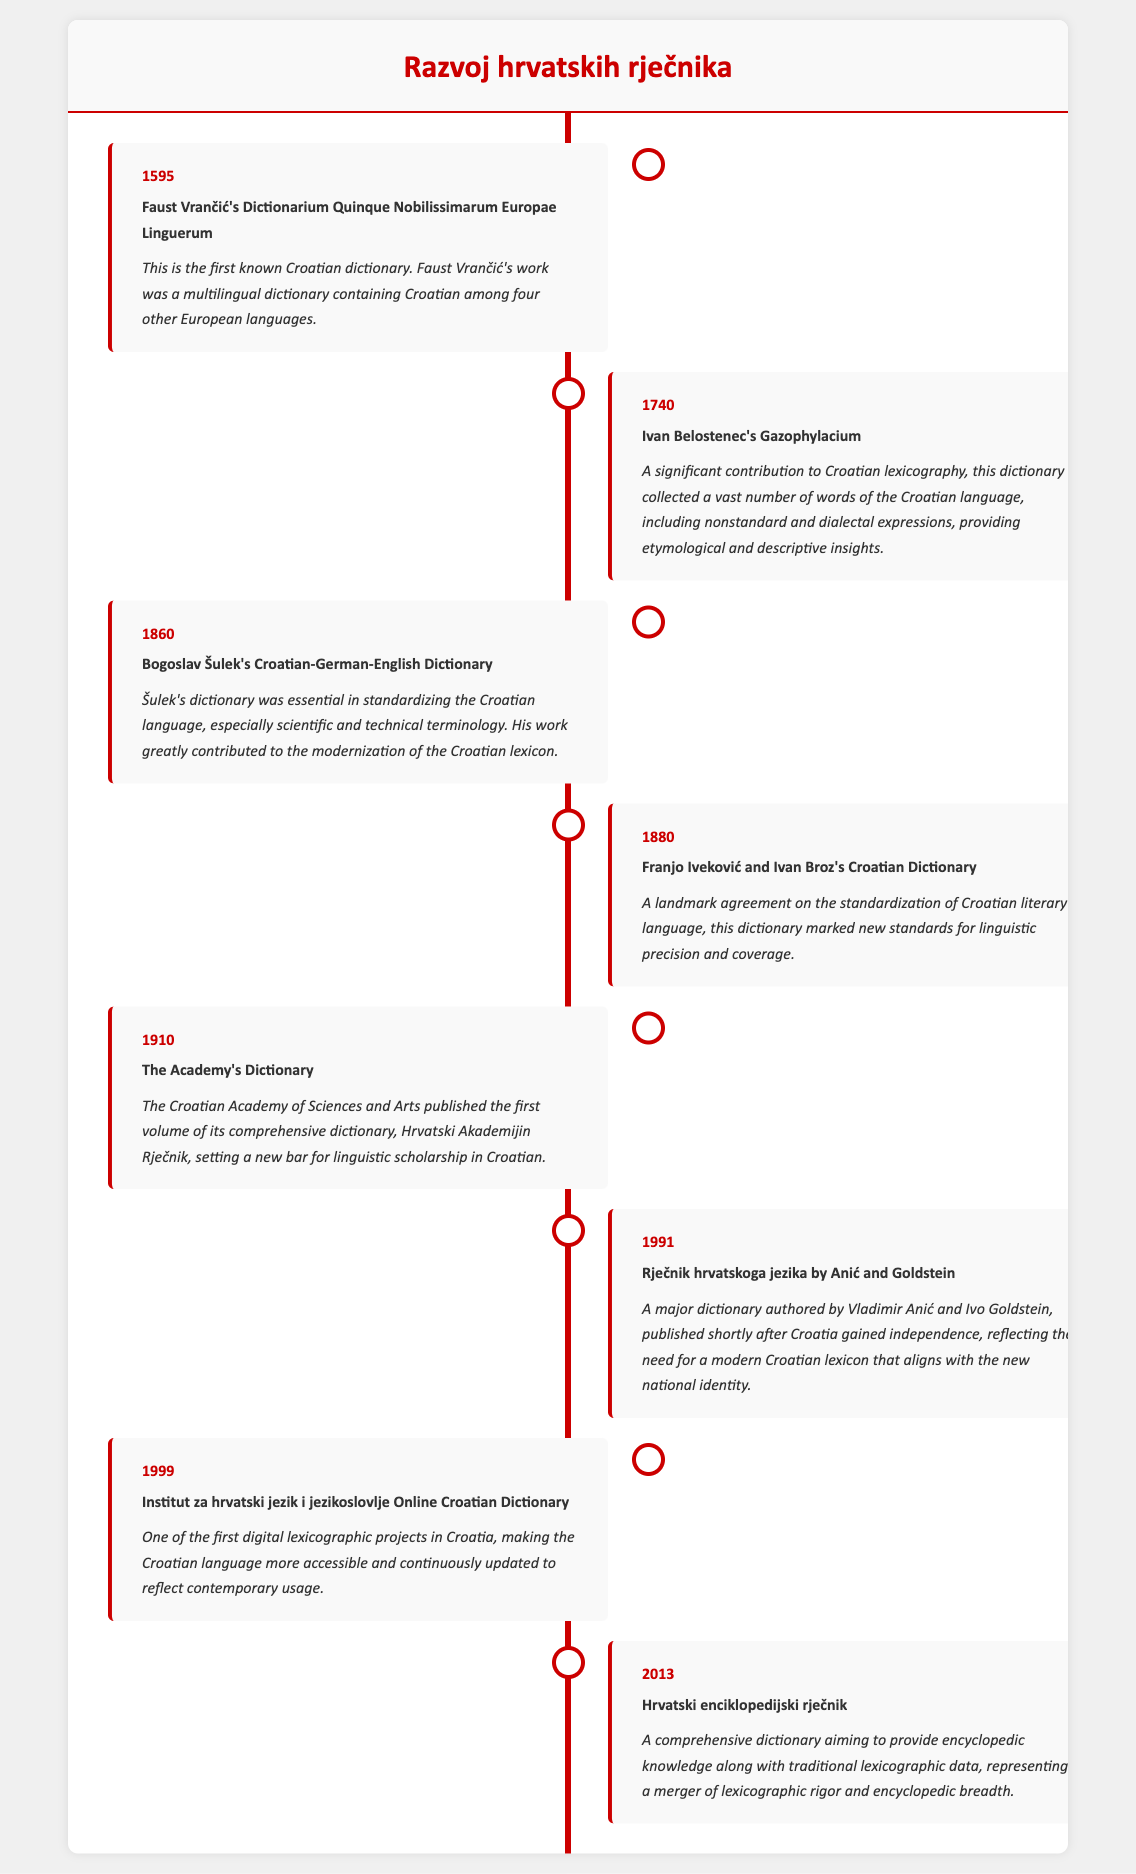What year was the first known Croatian dictionary published? The document mentions that the first known Croatian dictionary, Faust Vrančić's Dictionarium, was published in 1595.
Answer: 1595 Who authored the Croatian-German-English Dictionary in 1860? The document states that Bogoslav Šulek authored the Croatian-German-English Dictionary in 1860.
Answer: Bogoslav Šulek Which dictionary was published shortly after Croatia gained independence? The document indicates that the Rječnik hrvatskoga jezika by Anić and Goldstein was published shortly after independence in 1991.
Answer: Rječnik hrvatskoga jezika by Anić and Goldstein What significant achievement was made in 1910? The document notes that the Croatian Academy of Sciences and Arts published the first volume of its comprehensive dictionary in 1910.
Answer: The Academy's Dictionary In what year was the Online Croatian Dictionary initiated? According to the document, the Online Croatian Dictionary was initiated in 1999.
Answer: 1999 What was the primary objective of Ivan Belostenec's Gazophylacium? The description states that it aimed to collect a vast number of words of the Croatian language, providing etymological and descriptive insights.
Answer: Collection of Croatian words How did Bogoslav Šulek's dictionary contribute to the Croatian language? The document highlights that it was essential in standardizing the Croatian language, particularly scientific and technical terminology.
Answer: Standardizing the Croatian language Who contributed to the landmark agreement on the standardization of Croatian literary language in 1880? The document mentions that Franjo Iveković and Ivan Broz contributed to the standardization in 1880.
Answer: Franjo Iveković and Ivan Broz What type of information does the Hrvatski enciklopedijski rječnik aim to provide? The document describes it as a comprehensive dictionary aiming to merge lexicographic rigor with encyclopedic breadth.
Answer: Lexicographic rigor and encyclopedic breadth 